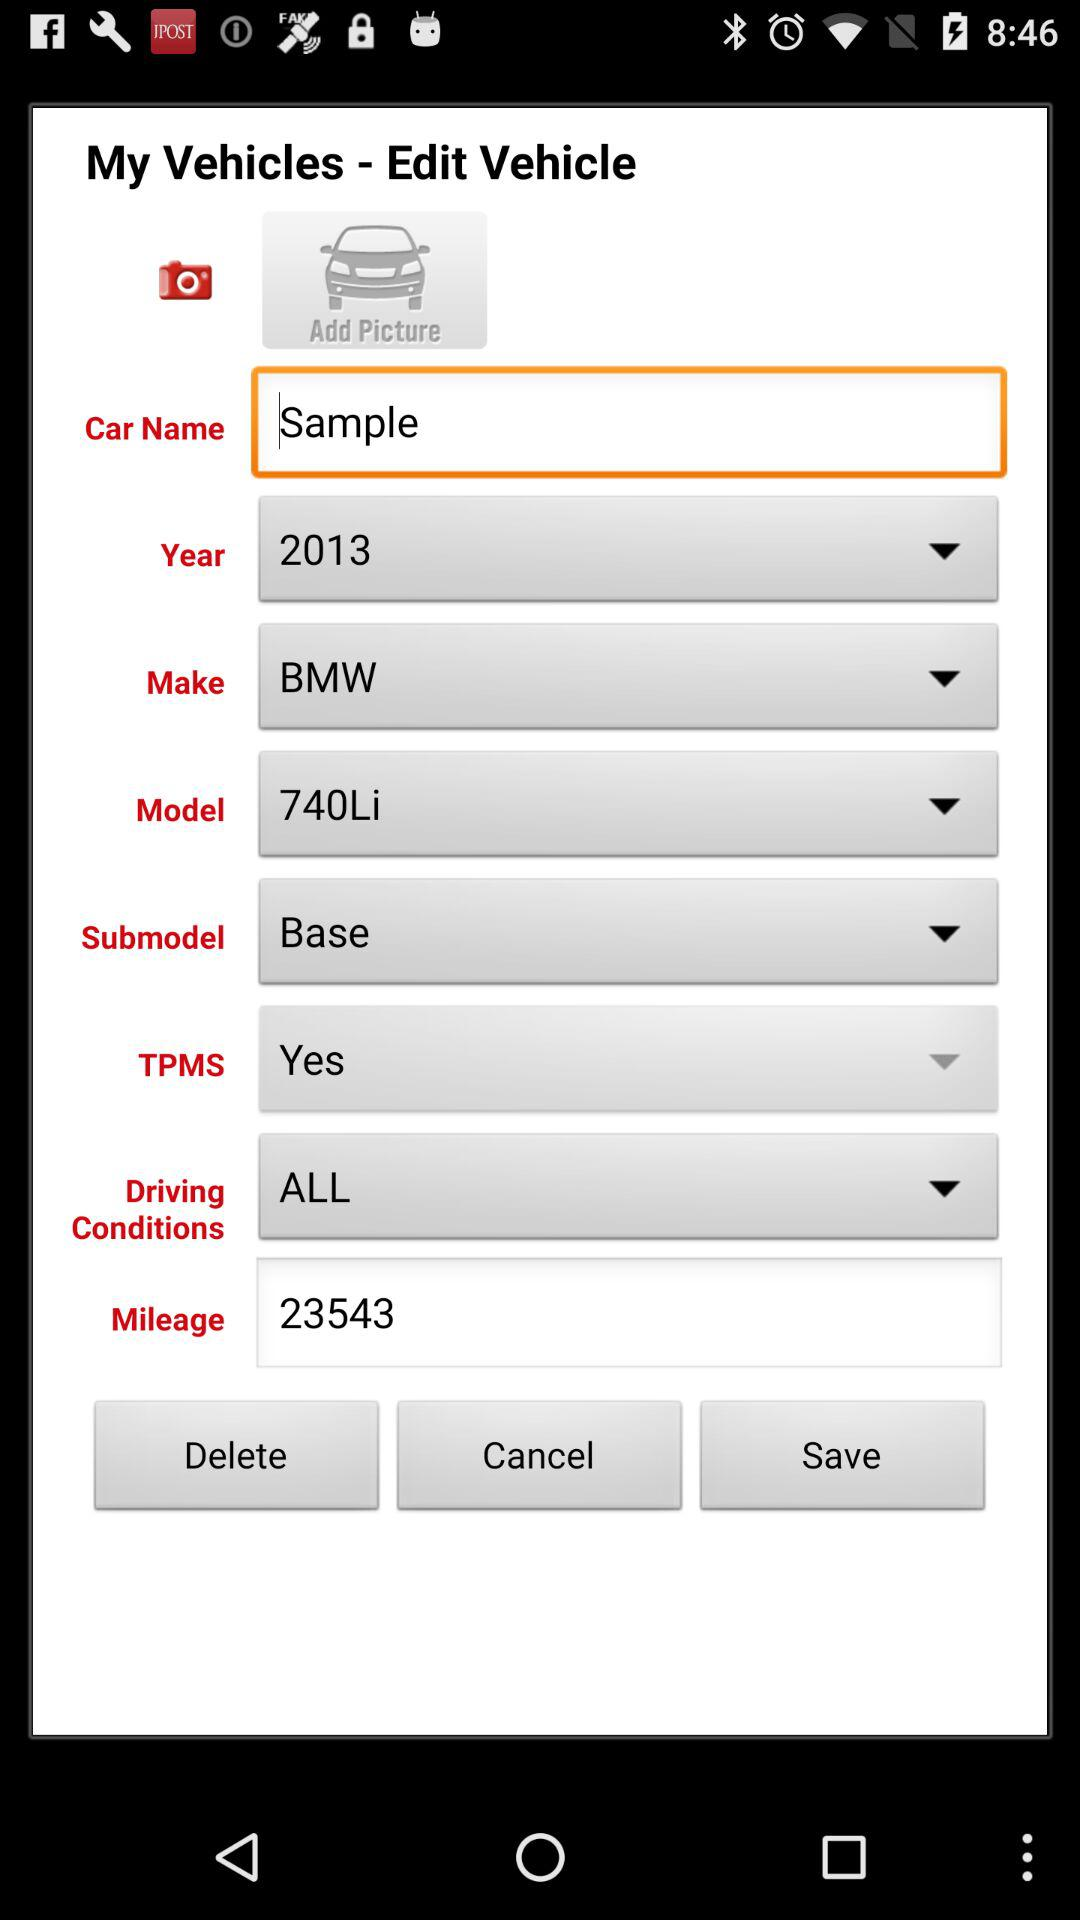What is the manufacturing year? The manufacturing year is 2013. 